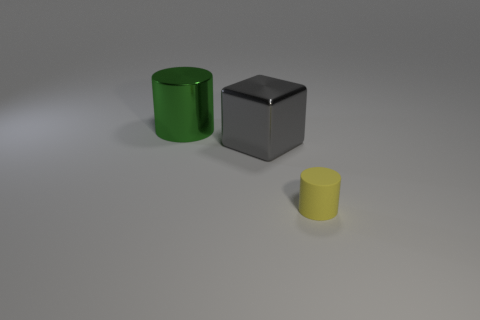What number of objects are either cylinders in front of the large green metal cylinder or objects on the left side of the tiny thing?
Your answer should be very brief. 3. Is the number of small red matte cubes less than the number of big cubes?
Offer a very short reply. Yes. There is a gray thing that is the same size as the green thing; what shape is it?
Offer a very short reply. Cube. How many other things are there of the same color as the large cube?
Offer a very short reply. 0. How many big yellow objects are there?
Offer a very short reply. 0. How many things are both in front of the big green shiny cylinder and on the left side of the small rubber object?
Give a very brief answer. 1. What is the material of the small yellow cylinder?
Make the answer very short. Rubber. Are any yellow rubber cylinders visible?
Ensure brevity in your answer.  Yes. The cylinder on the left side of the small object is what color?
Give a very brief answer. Green. There is a cylinder behind the cylinder that is in front of the large metallic cylinder; what number of yellow matte cylinders are on the right side of it?
Provide a succinct answer. 1. 